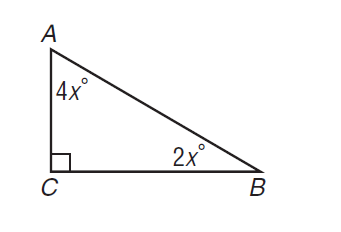Answer the mathemtical geometry problem and directly provide the correct option letter.
Question: In the right triangle, what is A B if B C = 6?
Choices: A: 2 \sqrt { 3 } B: 4 \sqrt { 3 } C: 6 \sqrt { 2 } D: 12 B 